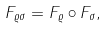<formula> <loc_0><loc_0><loc_500><loc_500>F _ { \varrho \sigma } = F _ { \varrho } \circ F _ { \sigma } ,</formula> 